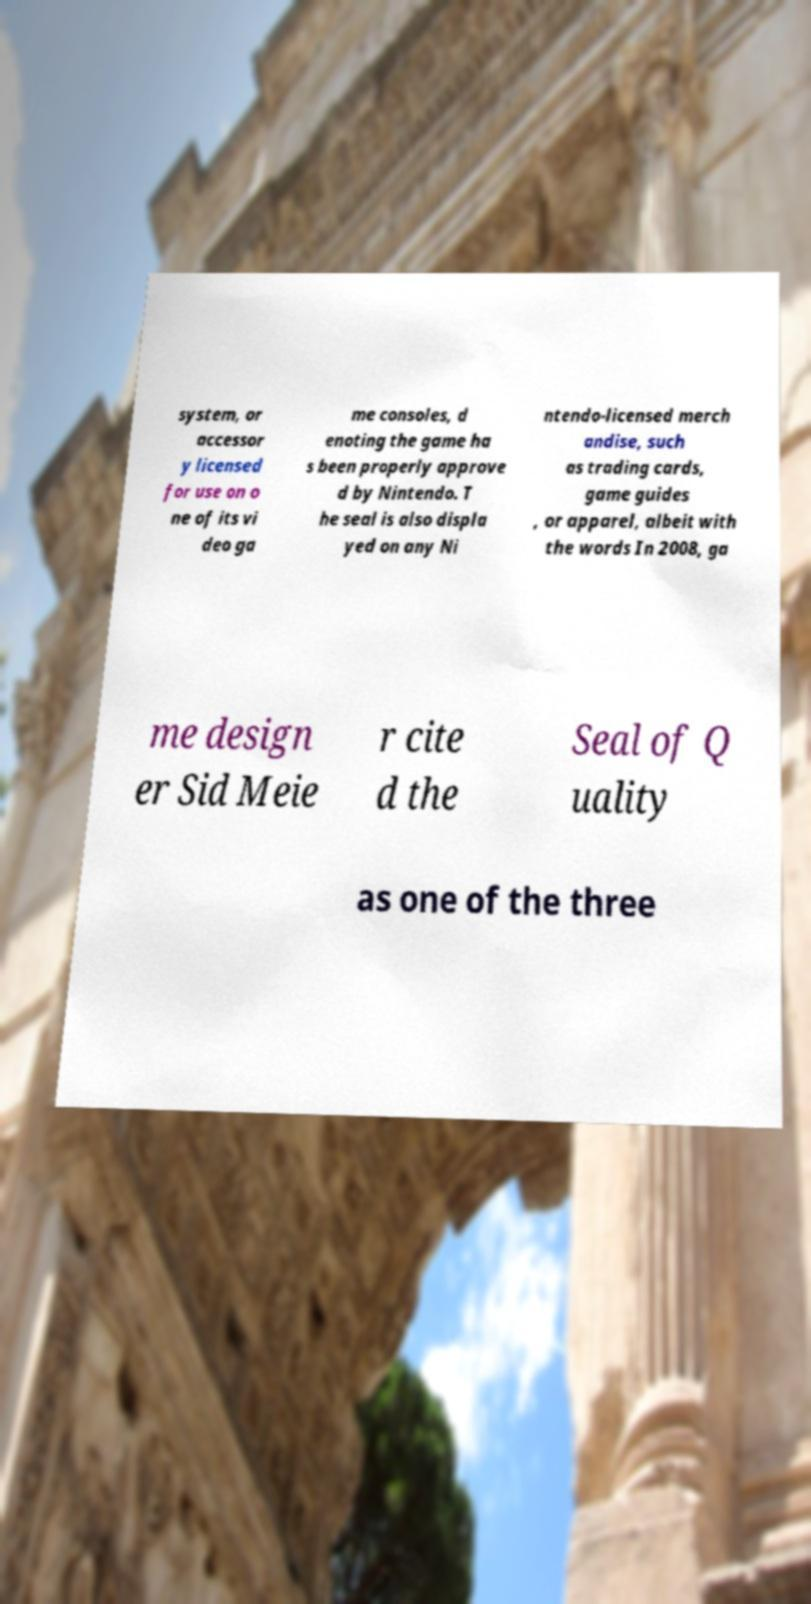Can you accurately transcribe the text from the provided image for me? system, or accessor y licensed for use on o ne of its vi deo ga me consoles, d enoting the game ha s been properly approve d by Nintendo. T he seal is also displa yed on any Ni ntendo-licensed merch andise, such as trading cards, game guides , or apparel, albeit with the words In 2008, ga me design er Sid Meie r cite d the Seal of Q uality as one of the three 